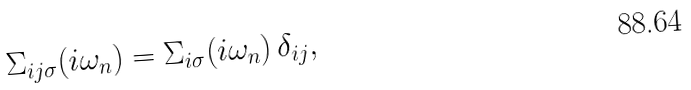Convert formula to latex. <formula><loc_0><loc_0><loc_500><loc_500>\Sigma _ { i j \sigma } ( i \omega _ { n } ) = \Sigma _ { i \sigma } ( i \omega _ { n } ) \, \delta _ { i j } ,</formula> 